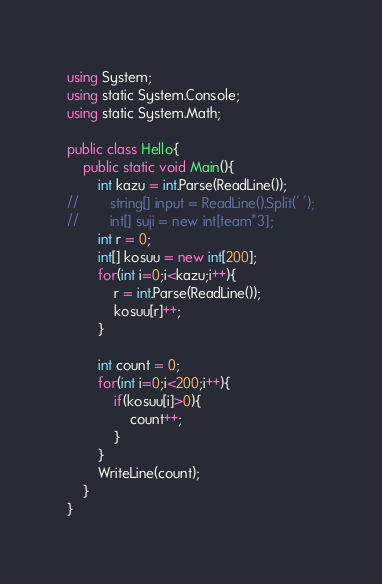Convert code to text. <code><loc_0><loc_0><loc_500><loc_500><_C#_>using System;
using static System.Console;
using static System.Math;

public class Hello{
    public static void Main(){
        int kazu = int.Parse(ReadLine());
//        string[] input = ReadLine().Split(' ');
//        int[] suji = new int[team*3];
        int r = 0;
        int[] kosuu = new int[200];
        for(int i=0;i<kazu;i++){
            r = int.Parse(ReadLine());
            kosuu[r]++;
        }

        int count = 0;
        for(int i=0;i<200;i++){
            if(kosuu[i]>0){
                count++;
            }
        }
        WriteLine(count);
    }
}</code> 